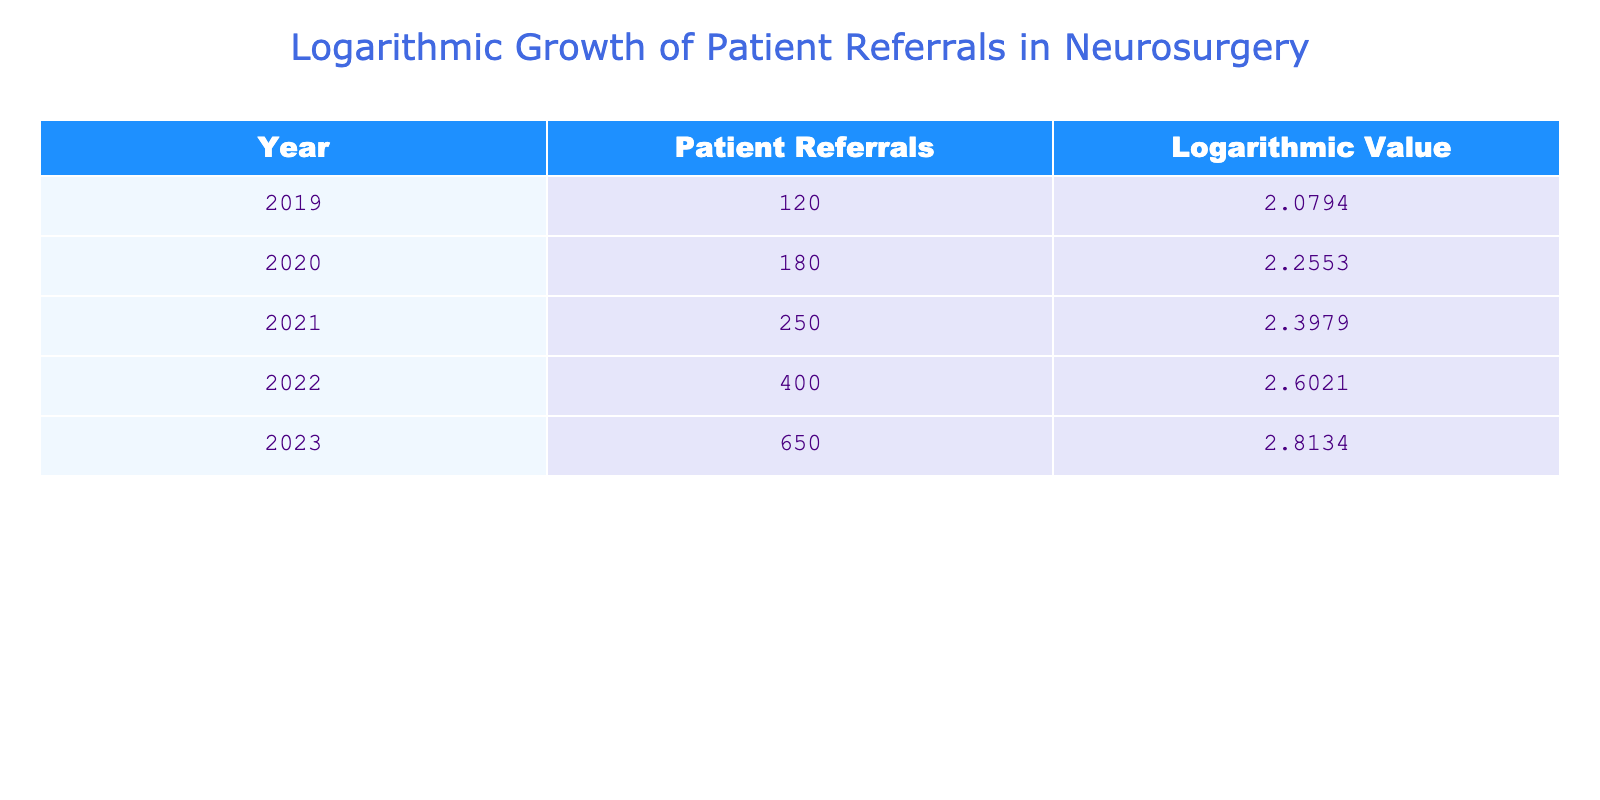What was the patient referral count in 2021? The table shows that in the year 2021, the patient referrals were listed as 250.
Answer: 250 What is the logarithmic value associated with the year 2020? Referring to the table, the logarithmic value for the year 2020 is noted as 2.2553.
Answer: 2.2553 What was the increase in patient referrals from 2019 to 2023? To find the increase, subtract the patient referrals in 2019 (120) from those in 2023 (650). The calculation is 650 - 120 = 530.
Answer: 530 Which year had the highest logarithmic value? By inspecting the logarithmic values listed in the table, 2023 has the highest value at 2.8134.
Answer: 2023 Was there an increase in patient referrals every year from 2019 to 2023? Observing the table, it is clear that the patient referrals increased each year without any declines, confirming a positive trend annually.
Answer: Yes What is the average number of patient referrals from 2019 to 2023? To calculate the average, sum all the patient referrals (120 + 180 + 250 + 400 + 650 = 1600) and divide by 5 (the number of years). Thus, 1600 / 5 = 320.
Answer: 320 How many more patient referrals were there in 2022 compared to 2020? The patient referrals for 2022 are 400, and for 2020 are 180. The difference is 400 - 180 = 220 referrals.
Answer: 220 What was the percentage increase in patient referrals from 2021 to 2022? The patient referrals increased from 250 in 2021 to 400 in 2022. The increase is 400 - 250 = 150. To find the percentage increase, divide the increase by the original value and multiply by 100: (150 / 250) * 100 = 60%.
Answer: 60% How do the logarithmic values correlate with patient referrals over the years? Observing the table, each year shows an increasing logarithmic value that corresponds directly with the rise in patient referrals, indicating a logarithmic growth pattern as referrals increase.
Answer: Increasing correlation 